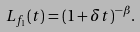Convert formula to latex. <formula><loc_0><loc_0><loc_500><loc_500>L _ { f _ { 1 } } ( t ) = ( 1 + \delta t ) ^ { - \beta } .</formula> 